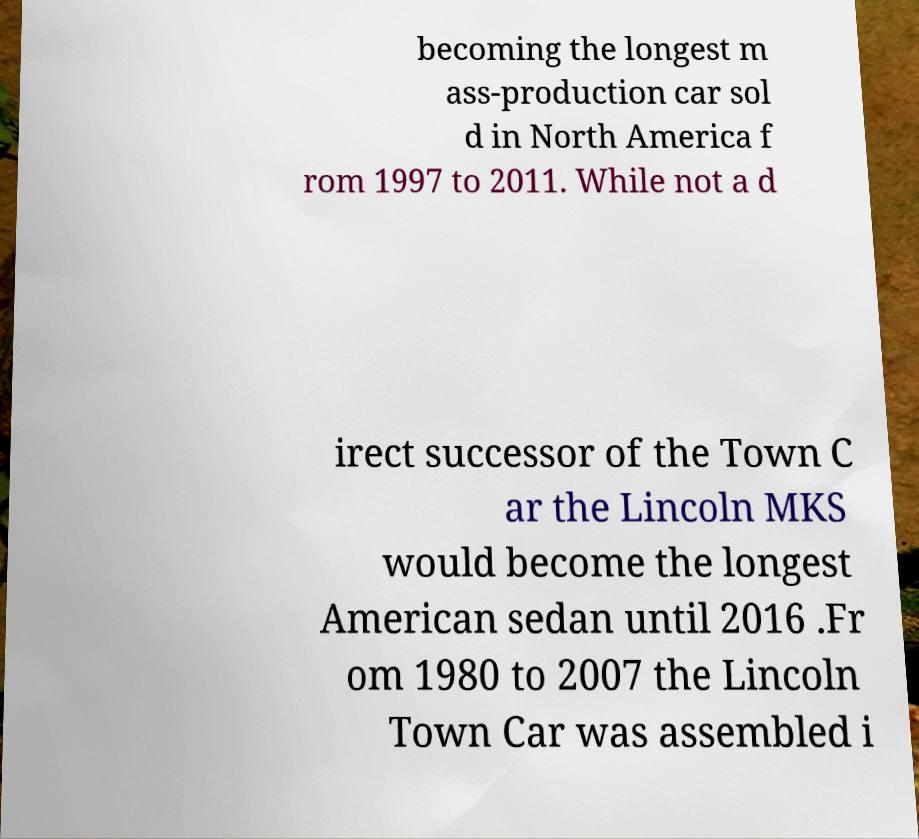Can you read and provide the text displayed in the image?This photo seems to have some interesting text. Can you extract and type it out for me? becoming the longest m ass-production car sol d in North America f rom 1997 to 2011. While not a d irect successor of the Town C ar the Lincoln MKS would become the longest American sedan until 2016 .Fr om 1980 to 2007 the Lincoln Town Car was assembled i 